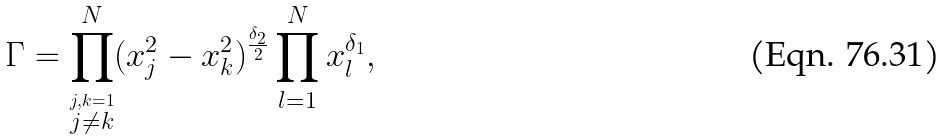Convert formula to latex. <formula><loc_0><loc_0><loc_500><loc_500>\Gamma = \prod _ { \stackrel { j , k = 1 } { j \neq k } } ^ { N } ( x _ { j } ^ { 2 } - x _ { k } ^ { 2 } ) ^ { \frac { \delta _ { 2 } } { 2 } } \prod _ { l = 1 } ^ { N } x _ { l } ^ { \delta _ { 1 } } ,</formula> 